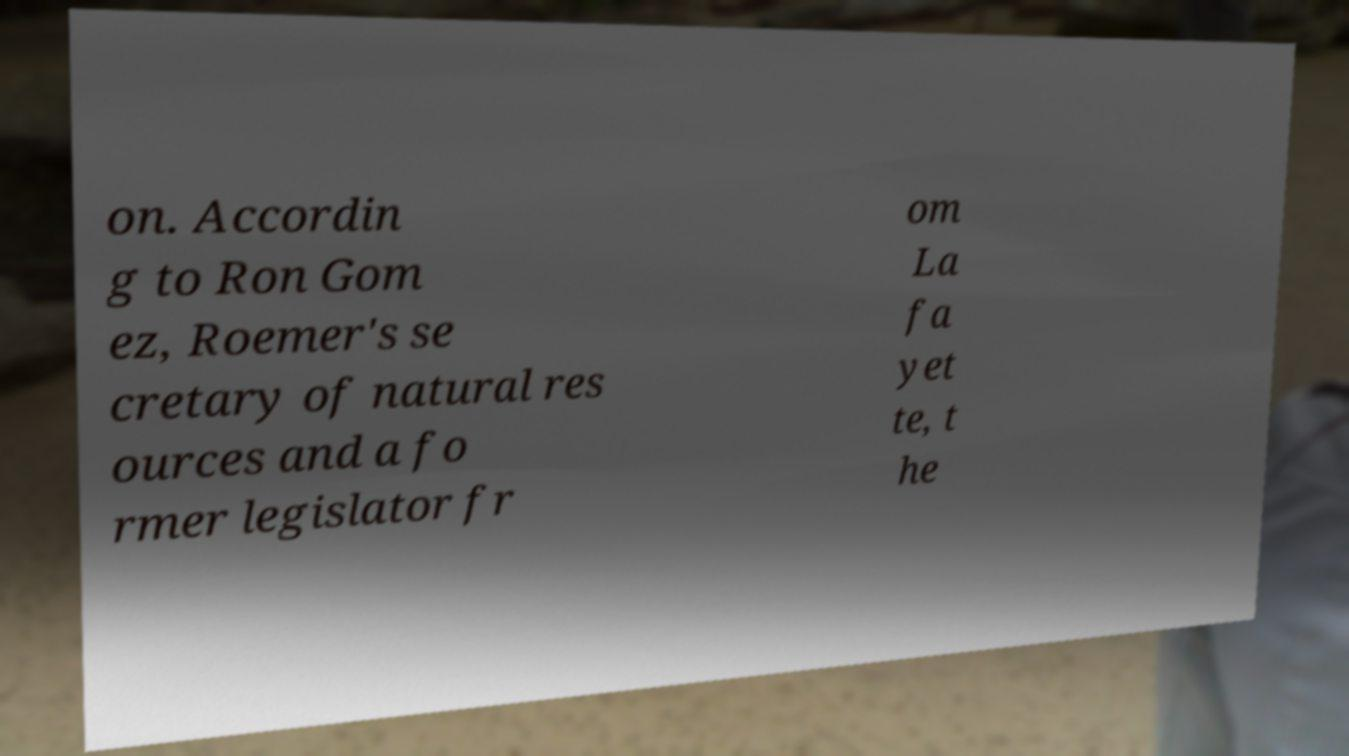Can you accurately transcribe the text from the provided image for me? on. Accordin g to Ron Gom ez, Roemer's se cretary of natural res ources and a fo rmer legislator fr om La fa yet te, t he 